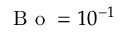Convert formula to latex. <formula><loc_0><loc_0><loc_500><loc_500>B o = 1 0 ^ { - 1 }</formula> 